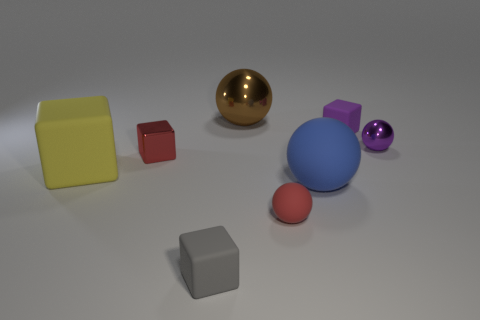Subtract all tiny purple blocks. How many blocks are left? 3 Add 2 yellow matte cubes. How many objects exist? 10 Subtract all purple cubes. How many cubes are left? 3 Subtract all brown cylinders. How many cyan spheres are left? 0 Subtract all blocks. Subtract all blue matte spheres. How many objects are left? 3 Add 2 red cubes. How many red cubes are left? 3 Add 6 big purple metal cylinders. How many big purple metal cylinders exist? 6 Subtract 0 yellow spheres. How many objects are left? 8 Subtract 2 spheres. How many spheres are left? 2 Subtract all red cubes. Subtract all cyan cylinders. How many cubes are left? 3 